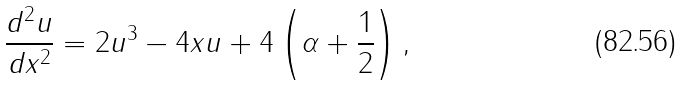Convert formula to latex. <formula><loc_0><loc_0><loc_500><loc_500>\frac { d ^ { 2 } u } { d x ^ { 2 } } = 2 u ^ { 3 } - 4 x u + 4 \left ( \alpha + \frac { 1 } { 2 } \right ) ,</formula> 